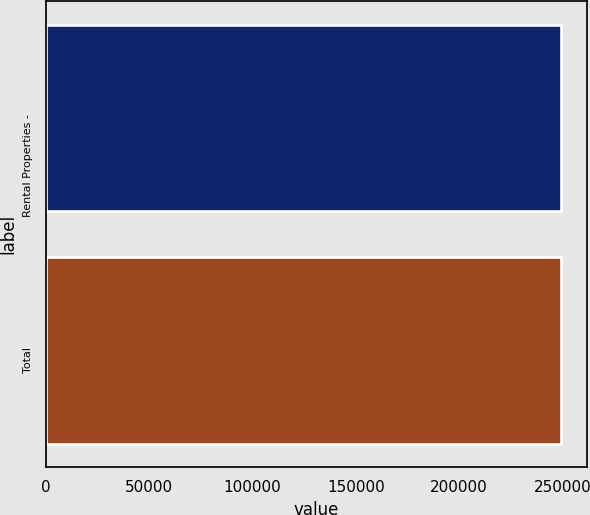<chart> <loc_0><loc_0><loc_500><loc_500><bar_chart><fcel>Rental Properties -<fcel>Total<nl><fcel>249334<fcel>249334<nl></chart> 